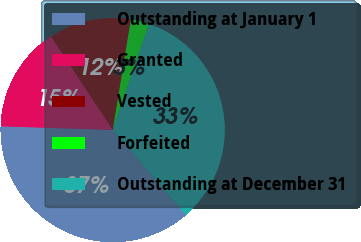Convert chart. <chart><loc_0><loc_0><loc_500><loc_500><pie_chart><fcel>Outstanding at January 1<fcel>Granted<fcel>Vested<fcel>Forfeited<fcel>Outstanding at December 31<nl><fcel>36.81%<fcel>15.21%<fcel>11.87%<fcel>2.64%<fcel>33.48%<nl></chart> 